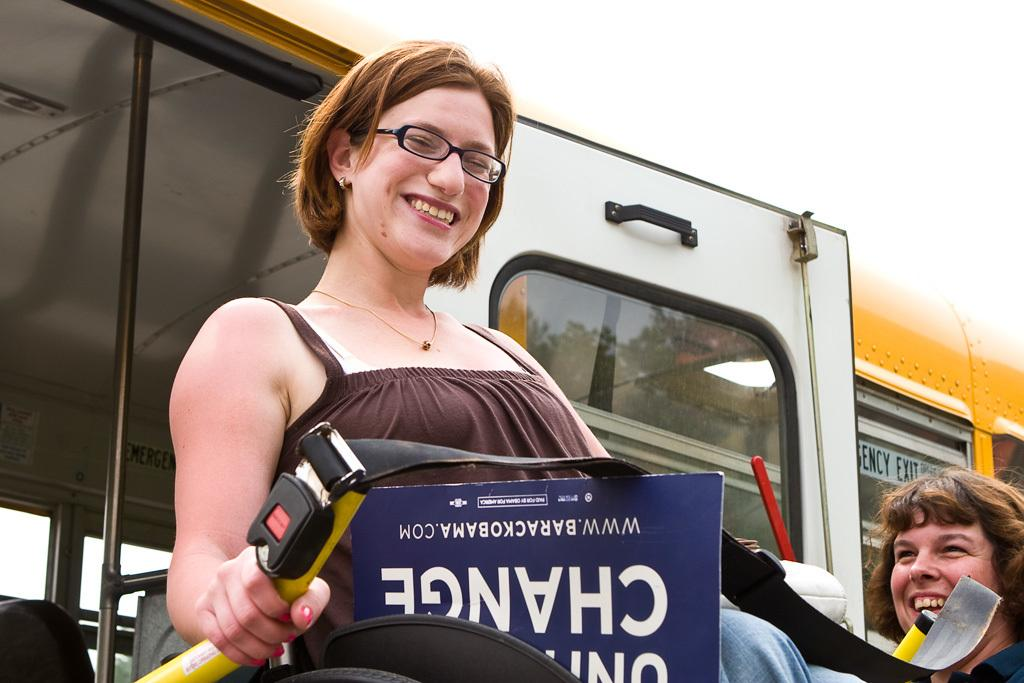What is the person in the image doing? The person is sitting on a chair in the image. What is the facial expression of the person? The person is smiling. What can be seen in the background of the image? There is a vehicle and another person in the background of the image. What type of minister is present in the image? There is no minister present in the image. Can you tell me how many drawers are visible in the image? There is no mention of a drawer or any furniture with drawers in the image. 